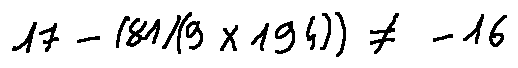<formula> <loc_0><loc_0><loc_500><loc_500>1 7 - ( 8 1 / ( 9 \times 1 9 4 ) ) \neq - 1 6</formula> 